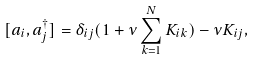Convert formula to latex. <formula><loc_0><loc_0><loc_500><loc_500>[ a _ { i } , a _ { j } ^ { \dagger } ] = \delta _ { i j } ( 1 + \nu \sum _ { k = 1 } ^ { N } K _ { i k } ) - \nu K _ { i j } ,</formula> 